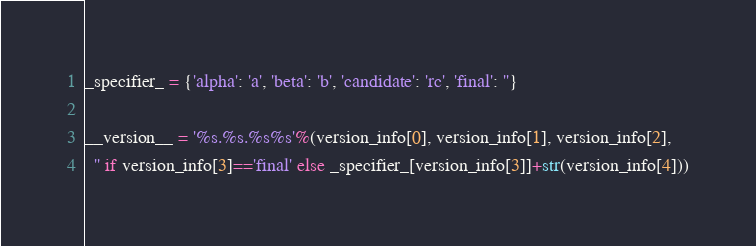Convert code to text. <code><loc_0><loc_0><loc_500><loc_500><_Python_>
_specifier_ = {'alpha': 'a', 'beta': 'b', 'candidate': 'rc', 'final': ''}

__version__ = '%s.%s.%s%s'%(version_info[0], version_info[1], version_info[2],
  '' if version_info[3]=='final' else _specifier_[version_info[3]]+str(version_info[4]))
</code> 